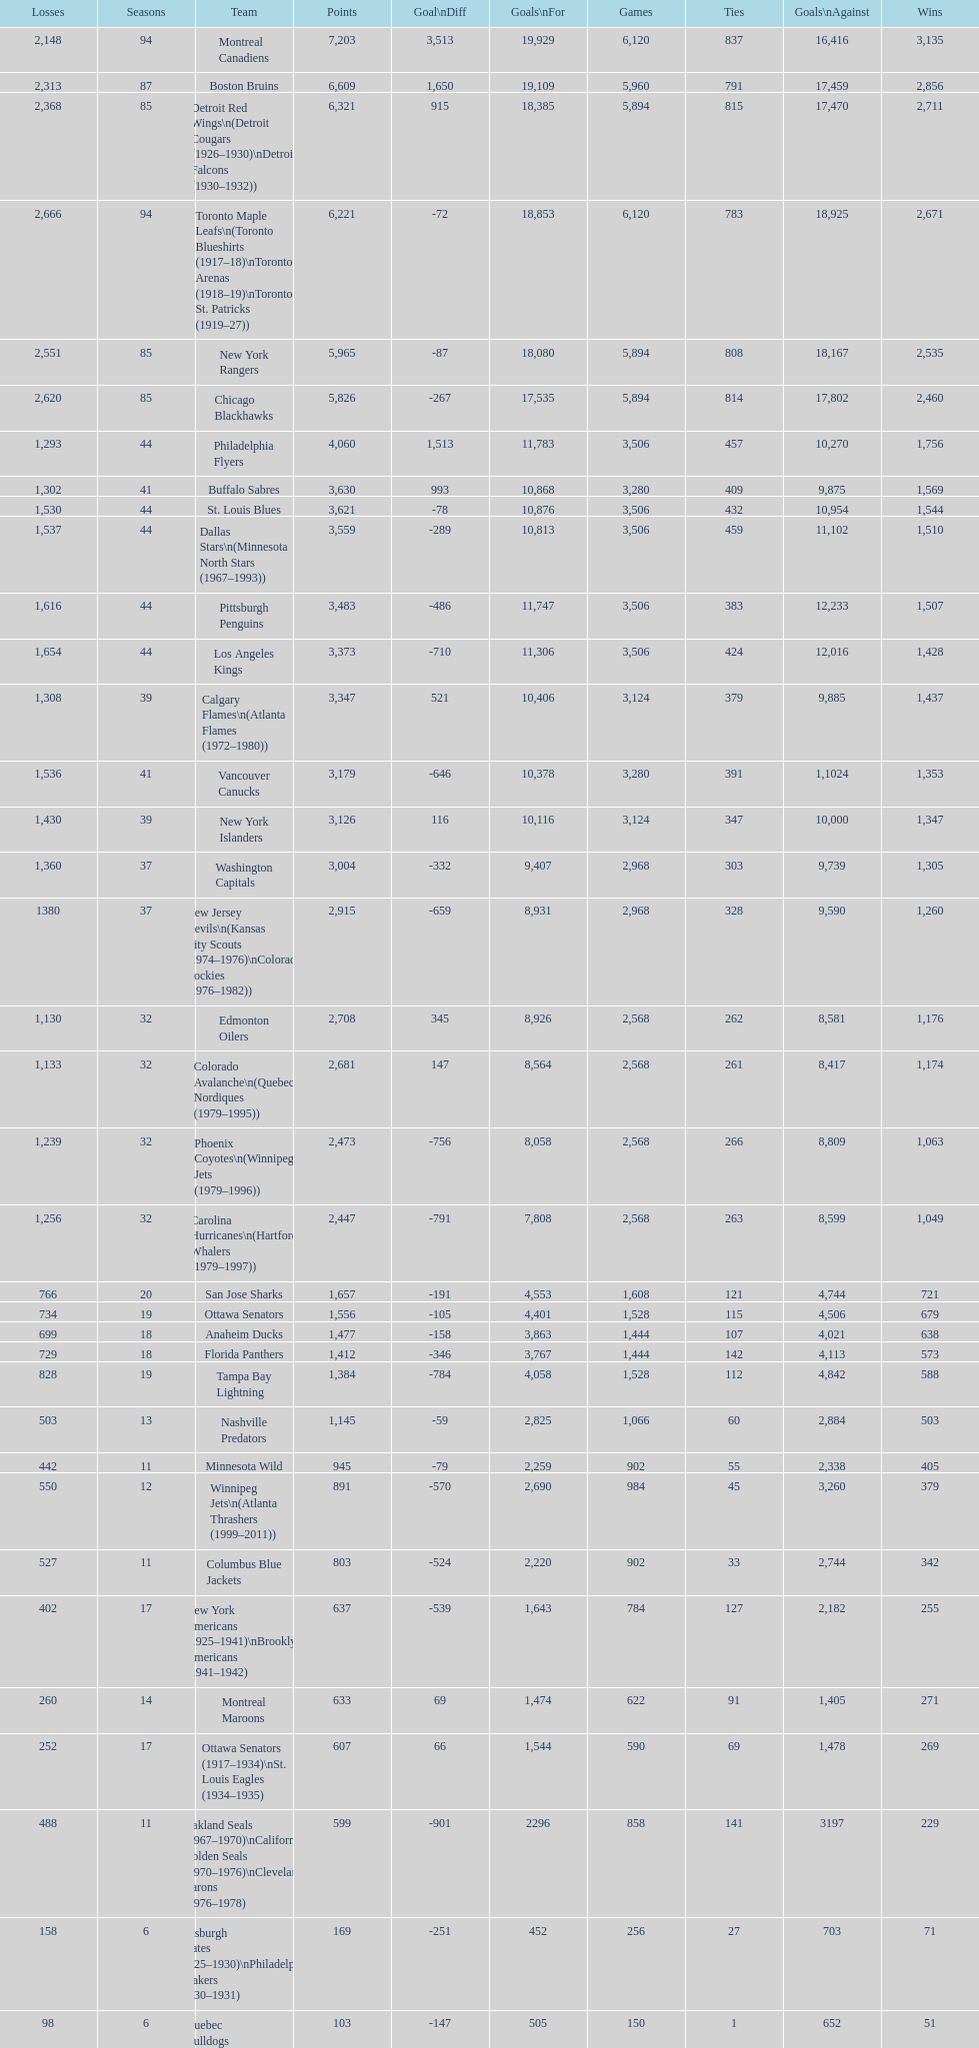Who has the least amount of losses? Montreal Wanderers. 